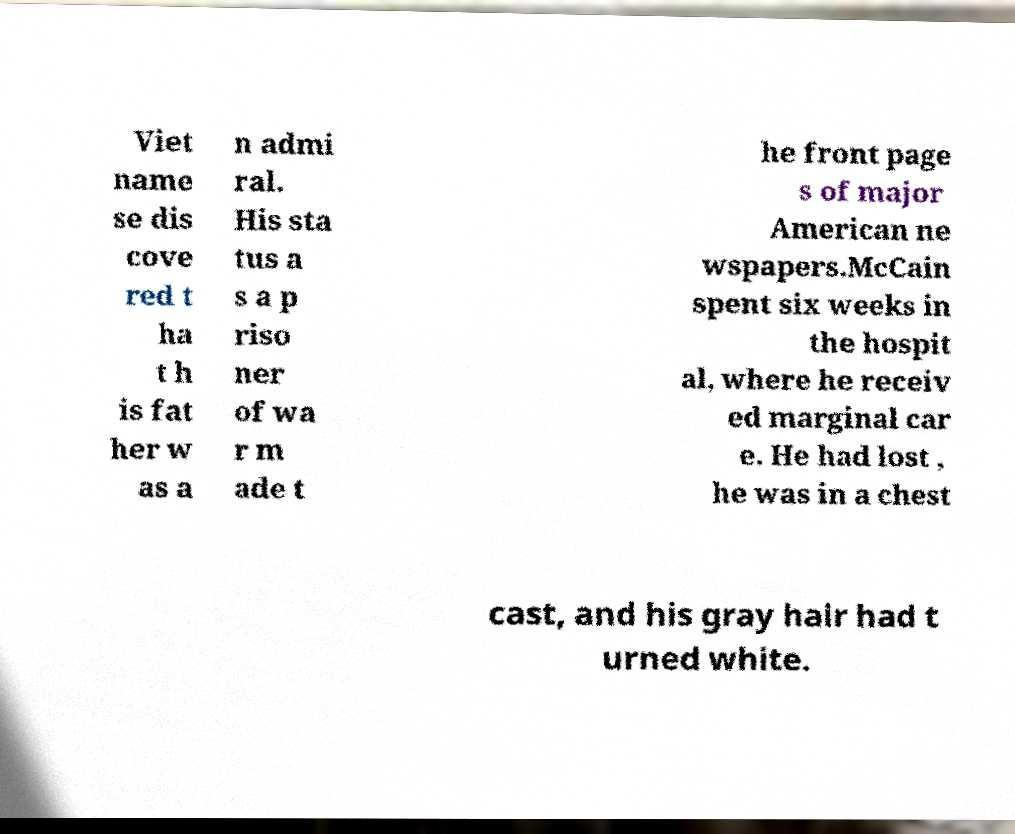There's text embedded in this image that I need extracted. Can you transcribe it verbatim? Viet name se dis cove red t ha t h is fat her w as a n admi ral. His sta tus a s a p riso ner of wa r m ade t he front page s of major American ne wspapers.McCain spent six weeks in the hospit al, where he receiv ed marginal car e. He had lost , he was in a chest cast, and his gray hair had t urned white. 